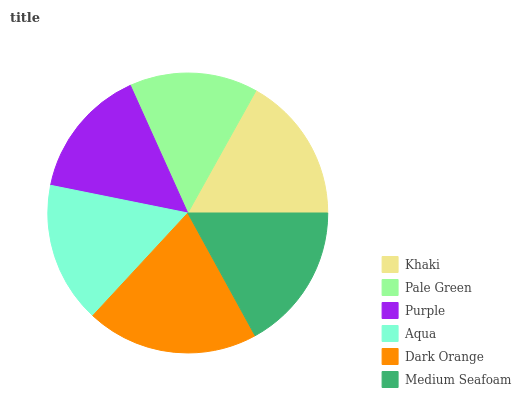Is Pale Green the minimum?
Answer yes or no. Yes. Is Dark Orange the maximum?
Answer yes or no. Yes. Is Purple the minimum?
Answer yes or no. No. Is Purple the maximum?
Answer yes or no. No. Is Purple greater than Pale Green?
Answer yes or no. Yes. Is Pale Green less than Purple?
Answer yes or no. Yes. Is Pale Green greater than Purple?
Answer yes or no. No. Is Purple less than Pale Green?
Answer yes or no. No. Is Khaki the high median?
Answer yes or no. Yes. Is Aqua the low median?
Answer yes or no. Yes. Is Pale Green the high median?
Answer yes or no. No. Is Dark Orange the low median?
Answer yes or no. No. 